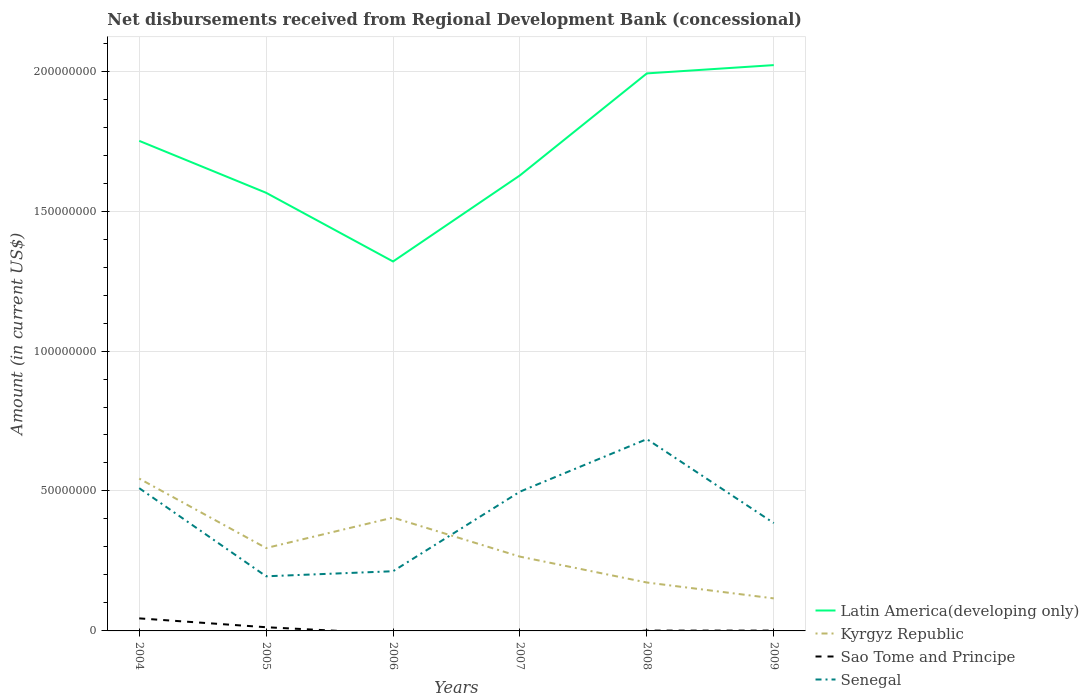Is the number of lines equal to the number of legend labels?
Ensure brevity in your answer.  No. Across all years, what is the maximum amount of disbursements received from Regional Development Bank in Kyrgyz Republic?
Ensure brevity in your answer.  1.16e+07. What is the total amount of disbursements received from Regional Development Bank in Kyrgyz Republic in the graph?
Your response must be concise. 3.71e+07. What is the difference between the highest and the second highest amount of disbursements received from Regional Development Bank in Senegal?
Offer a terse response. 4.90e+07. What is the difference between the highest and the lowest amount of disbursements received from Regional Development Bank in Senegal?
Keep it short and to the point. 3. How many lines are there?
Your answer should be very brief. 4. What is the difference between two consecutive major ticks on the Y-axis?
Offer a terse response. 5.00e+07. Does the graph contain any zero values?
Provide a short and direct response. Yes. Does the graph contain grids?
Provide a succinct answer. Yes. How are the legend labels stacked?
Provide a succinct answer. Vertical. What is the title of the graph?
Offer a very short reply. Net disbursements received from Regional Development Bank (concessional). What is the label or title of the X-axis?
Your response must be concise. Years. What is the Amount (in current US$) of Latin America(developing only) in 2004?
Make the answer very short. 1.75e+08. What is the Amount (in current US$) in Kyrgyz Republic in 2004?
Provide a short and direct response. 5.44e+07. What is the Amount (in current US$) of Sao Tome and Principe in 2004?
Your answer should be compact. 4.48e+06. What is the Amount (in current US$) of Senegal in 2004?
Provide a succinct answer. 5.10e+07. What is the Amount (in current US$) of Latin America(developing only) in 2005?
Provide a succinct answer. 1.57e+08. What is the Amount (in current US$) of Kyrgyz Republic in 2005?
Offer a very short reply. 2.96e+07. What is the Amount (in current US$) of Sao Tome and Principe in 2005?
Offer a very short reply. 1.32e+06. What is the Amount (in current US$) in Senegal in 2005?
Your answer should be very brief. 1.95e+07. What is the Amount (in current US$) of Latin America(developing only) in 2006?
Give a very brief answer. 1.32e+08. What is the Amount (in current US$) of Kyrgyz Republic in 2006?
Provide a succinct answer. 4.05e+07. What is the Amount (in current US$) of Sao Tome and Principe in 2006?
Offer a terse response. 0. What is the Amount (in current US$) in Senegal in 2006?
Your answer should be compact. 2.13e+07. What is the Amount (in current US$) of Latin America(developing only) in 2007?
Ensure brevity in your answer.  1.63e+08. What is the Amount (in current US$) of Kyrgyz Republic in 2007?
Provide a succinct answer. 2.65e+07. What is the Amount (in current US$) of Senegal in 2007?
Provide a succinct answer. 4.98e+07. What is the Amount (in current US$) of Latin America(developing only) in 2008?
Your response must be concise. 1.99e+08. What is the Amount (in current US$) of Kyrgyz Republic in 2008?
Keep it short and to the point. 1.73e+07. What is the Amount (in current US$) of Sao Tome and Principe in 2008?
Offer a very short reply. 1.18e+05. What is the Amount (in current US$) of Senegal in 2008?
Provide a succinct answer. 6.85e+07. What is the Amount (in current US$) of Latin America(developing only) in 2009?
Give a very brief answer. 2.02e+08. What is the Amount (in current US$) of Kyrgyz Republic in 2009?
Provide a short and direct response. 1.16e+07. What is the Amount (in current US$) of Senegal in 2009?
Your answer should be compact. 3.85e+07. Across all years, what is the maximum Amount (in current US$) of Latin America(developing only)?
Give a very brief answer. 2.02e+08. Across all years, what is the maximum Amount (in current US$) of Kyrgyz Republic?
Offer a terse response. 5.44e+07. Across all years, what is the maximum Amount (in current US$) of Sao Tome and Principe?
Offer a very short reply. 4.48e+06. Across all years, what is the maximum Amount (in current US$) of Senegal?
Your answer should be very brief. 6.85e+07. Across all years, what is the minimum Amount (in current US$) in Latin America(developing only)?
Keep it short and to the point. 1.32e+08. Across all years, what is the minimum Amount (in current US$) of Kyrgyz Republic?
Ensure brevity in your answer.  1.16e+07. Across all years, what is the minimum Amount (in current US$) in Senegal?
Your response must be concise. 1.95e+07. What is the total Amount (in current US$) in Latin America(developing only) in the graph?
Your response must be concise. 1.03e+09. What is the total Amount (in current US$) of Kyrgyz Republic in the graph?
Your answer should be very brief. 1.80e+08. What is the total Amount (in current US$) in Sao Tome and Principe in the graph?
Provide a short and direct response. 6.04e+06. What is the total Amount (in current US$) in Senegal in the graph?
Ensure brevity in your answer.  2.49e+08. What is the difference between the Amount (in current US$) in Latin America(developing only) in 2004 and that in 2005?
Offer a terse response. 1.86e+07. What is the difference between the Amount (in current US$) of Kyrgyz Republic in 2004 and that in 2005?
Your answer should be compact. 2.48e+07. What is the difference between the Amount (in current US$) of Sao Tome and Principe in 2004 and that in 2005?
Keep it short and to the point. 3.16e+06. What is the difference between the Amount (in current US$) in Senegal in 2004 and that in 2005?
Make the answer very short. 3.15e+07. What is the difference between the Amount (in current US$) in Latin America(developing only) in 2004 and that in 2006?
Ensure brevity in your answer.  4.31e+07. What is the difference between the Amount (in current US$) in Kyrgyz Republic in 2004 and that in 2006?
Make the answer very short. 1.39e+07. What is the difference between the Amount (in current US$) of Senegal in 2004 and that in 2006?
Give a very brief answer. 2.97e+07. What is the difference between the Amount (in current US$) in Latin America(developing only) in 2004 and that in 2007?
Your answer should be compact. 1.23e+07. What is the difference between the Amount (in current US$) of Kyrgyz Republic in 2004 and that in 2007?
Offer a terse response. 2.79e+07. What is the difference between the Amount (in current US$) in Senegal in 2004 and that in 2007?
Provide a short and direct response. 1.25e+06. What is the difference between the Amount (in current US$) of Latin America(developing only) in 2004 and that in 2008?
Give a very brief answer. -2.41e+07. What is the difference between the Amount (in current US$) of Kyrgyz Republic in 2004 and that in 2008?
Provide a short and direct response. 3.71e+07. What is the difference between the Amount (in current US$) of Sao Tome and Principe in 2004 and that in 2008?
Your response must be concise. 4.37e+06. What is the difference between the Amount (in current US$) of Senegal in 2004 and that in 2008?
Provide a short and direct response. -1.75e+07. What is the difference between the Amount (in current US$) in Latin America(developing only) in 2004 and that in 2009?
Keep it short and to the point. -2.71e+07. What is the difference between the Amount (in current US$) of Kyrgyz Republic in 2004 and that in 2009?
Ensure brevity in your answer.  4.28e+07. What is the difference between the Amount (in current US$) of Sao Tome and Principe in 2004 and that in 2009?
Make the answer very short. 4.36e+06. What is the difference between the Amount (in current US$) in Senegal in 2004 and that in 2009?
Offer a terse response. 1.25e+07. What is the difference between the Amount (in current US$) of Latin America(developing only) in 2005 and that in 2006?
Your response must be concise. 2.45e+07. What is the difference between the Amount (in current US$) of Kyrgyz Republic in 2005 and that in 2006?
Your answer should be compact. -1.09e+07. What is the difference between the Amount (in current US$) of Senegal in 2005 and that in 2006?
Provide a succinct answer. -1.80e+06. What is the difference between the Amount (in current US$) of Latin America(developing only) in 2005 and that in 2007?
Make the answer very short. -6.22e+06. What is the difference between the Amount (in current US$) of Kyrgyz Republic in 2005 and that in 2007?
Keep it short and to the point. 3.07e+06. What is the difference between the Amount (in current US$) in Senegal in 2005 and that in 2007?
Keep it short and to the point. -3.02e+07. What is the difference between the Amount (in current US$) in Latin America(developing only) in 2005 and that in 2008?
Offer a very short reply. -4.27e+07. What is the difference between the Amount (in current US$) of Kyrgyz Republic in 2005 and that in 2008?
Ensure brevity in your answer.  1.23e+07. What is the difference between the Amount (in current US$) of Sao Tome and Principe in 2005 and that in 2008?
Your answer should be very brief. 1.20e+06. What is the difference between the Amount (in current US$) in Senegal in 2005 and that in 2008?
Keep it short and to the point. -4.90e+07. What is the difference between the Amount (in current US$) in Latin America(developing only) in 2005 and that in 2009?
Ensure brevity in your answer.  -4.56e+07. What is the difference between the Amount (in current US$) of Kyrgyz Republic in 2005 and that in 2009?
Your answer should be compact. 1.80e+07. What is the difference between the Amount (in current US$) of Sao Tome and Principe in 2005 and that in 2009?
Offer a very short reply. 1.20e+06. What is the difference between the Amount (in current US$) in Senegal in 2005 and that in 2009?
Your answer should be compact. -1.90e+07. What is the difference between the Amount (in current US$) in Latin America(developing only) in 2006 and that in 2007?
Your answer should be compact. -3.08e+07. What is the difference between the Amount (in current US$) in Kyrgyz Republic in 2006 and that in 2007?
Give a very brief answer. 1.39e+07. What is the difference between the Amount (in current US$) in Senegal in 2006 and that in 2007?
Your answer should be very brief. -2.84e+07. What is the difference between the Amount (in current US$) in Latin America(developing only) in 2006 and that in 2008?
Offer a terse response. -6.72e+07. What is the difference between the Amount (in current US$) in Kyrgyz Republic in 2006 and that in 2008?
Keep it short and to the point. 2.32e+07. What is the difference between the Amount (in current US$) in Senegal in 2006 and that in 2008?
Make the answer very short. -4.72e+07. What is the difference between the Amount (in current US$) in Latin America(developing only) in 2006 and that in 2009?
Your response must be concise. -7.02e+07. What is the difference between the Amount (in current US$) of Kyrgyz Republic in 2006 and that in 2009?
Give a very brief answer. 2.89e+07. What is the difference between the Amount (in current US$) in Senegal in 2006 and that in 2009?
Offer a very short reply. -1.72e+07. What is the difference between the Amount (in current US$) in Latin America(developing only) in 2007 and that in 2008?
Your response must be concise. -3.64e+07. What is the difference between the Amount (in current US$) in Kyrgyz Republic in 2007 and that in 2008?
Offer a terse response. 9.25e+06. What is the difference between the Amount (in current US$) of Senegal in 2007 and that in 2008?
Offer a terse response. -1.88e+07. What is the difference between the Amount (in current US$) in Latin America(developing only) in 2007 and that in 2009?
Offer a terse response. -3.94e+07. What is the difference between the Amount (in current US$) in Kyrgyz Republic in 2007 and that in 2009?
Your answer should be very brief. 1.49e+07. What is the difference between the Amount (in current US$) in Senegal in 2007 and that in 2009?
Provide a succinct answer. 1.12e+07. What is the difference between the Amount (in current US$) in Latin America(developing only) in 2008 and that in 2009?
Offer a terse response. -2.96e+06. What is the difference between the Amount (in current US$) in Kyrgyz Republic in 2008 and that in 2009?
Your answer should be very brief. 5.67e+06. What is the difference between the Amount (in current US$) of Sao Tome and Principe in 2008 and that in 2009?
Your answer should be very brief. -2000. What is the difference between the Amount (in current US$) of Senegal in 2008 and that in 2009?
Your answer should be very brief. 3.00e+07. What is the difference between the Amount (in current US$) in Latin America(developing only) in 2004 and the Amount (in current US$) in Kyrgyz Republic in 2005?
Give a very brief answer. 1.45e+08. What is the difference between the Amount (in current US$) of Latin America(developing only) in 2004 and the Amount (in current US$) of Sao Tome and Principe in 2005?
Your answer should be compact. 1.74e+08. What is the difference between the Amount (in current US$) of Latin America(developing only) in 2004 and the Amount (in current US$) of Senegal in 2005?
Ensure brevity in your answer.  1.56e+08. What is the difference between the Amount (in current US$) of Kyrgyz Republic in 2004 and the Amount (in current US$) of Sao Tome and Principe in 2005?
Your answer should be very brief. 5.31e+07. What is the difference between the Amount (in current US$) in Kyrgyz Republic in 2004 and the Amount (in current US$) in Senegal in 2005?
Offer a terse response. 3.49e+07. What is the difference between the Amount (in current US$) in Sao Tome and Principe in 2004 and the Amount (in current US$) in Senegal in 2005?
Offer a very short reply. -1.50e+07. What is the difference between the Amount (in current US$) in Latin America(developing only) in 2004 and the Amount (in current US$) in Kyrgyz Republic in 2006?
Your answer should be very brief. 1.35e+08. What is the difference between the Amount (in current US$) in Latin America(developing only) in 2004 and the Amount (in current US$) in Senegal in 2006?
Ensure brevity in your answer.  1.54e+08. What is the difference between the Amount (in current US$) in Kyrgyz Republic in 2004 and the Amount (in current US$) in Senegal in 2006?
Your response must be concise. 3.31e+07. What is the difference between the Amount (in current US$) of Sao Tome and Principe in 2004 and the Amount (in current US$) of Senegal in 2006?
Give a very brief answer. -1.68e+07. What is the difference between the Amount (in current US$) of Latin America(developing only) in 2004 and the Amount (in current US$) of Kyrgyz Republic in 2007?
Make the answer very short. 1.49e+08. What is the difference between the Amount (in current US$) in Latin America(developing only) in 2004 and the Amount (in current US$) in Senegal in 2007?
Your answer should be very brief. 1.25e+08. What is the difference between the Amount (in current US$) of Kyrgyz Republic in 2004 and the Amount (in current US$) of Senegal in 2007?
Keep it short and to the point. 4.66e+06. What is the difference between the Amount (in current US$) of Sao Tome and Principe in 2004 and the Amount (in current US$) of Senegal in 2007?
Your answer should be compact. -4.53e+07. What is the difference between the Amount (in current US$) of Latin America(developing only) in 2004 and the Amount (in current US$) of Kyrgyz Republic in 2008?
Provide a short and direct response. 1.58e+08. What is the difference between the Amount (in current US$) in Latin America(developing only) in 2004 and the Amount (in current US$) in Sao Tome and Principe in 2008?
Offer a very short reply. 1.75e+08. What is the difference between the Amount (in current US$) of Latin America(developing only) in 2004 and the Amount (in current US$) of Senegal in 2008?
Provide a succinct answer. 1.07e+08. What is the difference between the Amount (in current US$) in Kyrgyz Republic in 2004 and the Amount (in current US$) in Sao Tome and Principe in 2008?
Your answer should be very brief. 5.43e+07. What is the difference between the Amount (in current US$) in Kyrgyz Republic in 2004 and the Amount (in current US$) in Senegal in 2008?
Keep it short and to the point. -1.41e+07. What is the difference between the Amount (in current US$) in Sao Tome and Principe in 2004 and the Amount (in current US$) in Senegal in 2008?
Your answer should be very brief. -6.40e+07. What is the difference between the Amount (in current US$) in Latin America(developing only) in 2004 and the Amount (in current US$) in Kyrgyz Republic in 2009?
Provide a succinct answer. 1.63e+08. What is the difference between the Amount (in current US$) of Latin America(developing only) in 2004 and the Amount (in current US$) of Sao Tome and Principe in 2009?
Keep it short and to the point. 1.75e+08. What is the difference between the Amount (in current US$) of Latin America(developing only) in 2004 and the Amount (in current US$) of Senegal in 2009?
Keep it short and to the point. 1.37e+08. What is the difference between the Amount (in current US$) in Kyrgyz Republic in 2004 and the Amount (in current US$) in Sao Tome and Principe in 2009?
Ensure brevity in your answer.  5.43e+07. What is the difference between the Amount (in current US$) in Kyrgyz Republic in 2004 and the Amount (in current US$) in Senegal in 2009?
Your answer should be very brief. 1.59e+07. What is the difference between the Amount (in current US$) in Sao Tome and Principe in 2004 and the Amount (in current US$) in Senegal in 2009?
Make the answer very short. -3.40e+07. What is the difference between the Amount (in current US$) in Latin America(developing only) in 2005 and the Amount (in current US$) in Kyrgyz Republic in 2006?
Ensure brevity in your answer.  1.16e+08. What is the difference between the Amount (in current US$) of Latin America(developing only) in 2005 and the Amount (in current US$) of Senegal in 2006?
Make the answer very short. 1.35e+08. What is the difference between the Amount (in current US$) of Kyrgyz Republic in 2005 and the Amount (in current US$) of Senegal in 2006?
Offer a very short reply. 8.29e+06. What is the difference between the Amount (in current US$) in Sao Tome and Principe in 2005 and the Amount (in current US$) in Senegal in 2006?
Make the answer very short. -2.00e+07. What is the difference between the Amount (in current US$) of Latin America(developing only) in 2005 and the Amount (in current US$) of Kyrgyz Republic in 2007?
Give a very brief answer. 1.30e+08. What is the difference between the Amount (in current US$) in Latin America(developing only) in 2005 and the Amount (in current US$) in Senegal in 2007?
Your answer should be compact. 1.07e+08. What is the difference between the Amount (in current US$) in Kyrgyz Republic in 2005 and the Amount (in current US$) in Senegal in 2007?
Provide a short and direct response. -2.01e+07. What is the difference between the Amount (in current US$) of Sao Tome and Principe in 2005 and the Amount (in current US$) of Senegal in 2007?
Give a very brief answer. -4.84e+07. What is the difference between the Amount (in current US$) in Latin America(developing only) in 2005 and the Amount (in current US$) in Kyrgyz Republic in 2008?
Provide a short and direct response. 1.39e+08. What is the difference between the Amount (in current US$) of Latin America(developing only) in 2005 and the Amount (in current US$) of Sao Tome and Principe in 2008?
Offer a terse response. 1.56e+08. What is the difference between the Amount (in current US$) of Latin America(developing only) in 2005 and the Amount (in current US$) of Senegal in 2008?
Give a very brief answer. 8.80e+07. What is the difference between the Amount (in current US$) in Kyrgyz Republic in 2005 and the Amount (in current US$) in Sao Tome and Principe in 2008?
Offer a very short reply. 2.95e+07. What is the difference between the Amount (in current US$) of Kyrgyz Republic in 2005 and the Amount (in current US$) of Senegal in 2008?
Ensure brevity in your answer.  -3.89e+07. What is the difference between the Amount (in current US$) in Sao Tome and Principe in 2005 and the Amount (in current US$) in Senegal in 2008?
Offer a terse response. -6.72e+07. What is the difference between the Amount (in current US$) in Latin America(developing only) in 2005 and the Amount (in current US$) in Kyrgyz Republic in 2009?
Provide a short and direct response. 1.45e+08. What is the difference between the Amount (in current US$) of Latin America(developing only) in 2005 and the Amount (in current US$) of Sao Tome and Principe in 2009?
Provide a short and direct response. 1.56e+08. What is the difference between the Amount (in current US$) in Latin America(developing only) in 2005 and the Amount (in current US$) in Senegal in 2009?
Ensure brevity in your answer.  1.18e+08. What is the difference between the Amount (in current US$) of Kyrgyz Republic in 2005 and the Amount (in current US$) of Sao Tome and Principe in 2009?
Offer a terse response. 2.95e+07. What is the difference between the Amount (in current US$) of Kyrgyz Republic in 2005 and the Amount (in current US$) of Senegal in 2009?
Make the answer very short. -8.92e+06. What is the difference between the Amount (in current US$) of Sao Tome and Principe in 2005 and the Amount (in current US$) of Senegal in 2009?
Provide a succinct answer. -3.72e+07. What is the difference between the Amount (in current US$) in Latin America(developing only) in 2006 and the Amount (in current US$) in Kyrgyz Republic in 2007?
Offer a very short reply. 1.05e+08. What is the difference between the Amount (in current US$) of Latin America(developing only) in 2006 and the Amount (in current US$) of Senegal in 2007?
Offer a terse response. 8.22e+07. What is the difference between the Amount (in current US$) of Kyrgyz Republic in 2006 and the Amount (in current US$) of Senegal in 2007?
Provide a short and direct response. -9.27e+06. What is the difference between the Amount (in current US$) in Latin America(developing only) in 2006 and the Amount (in current US$) in Kyrgyz Republic in 2008?
Your response must be concise. 1.15e+08. What is the difference between the Amount (in current US$) in Latin America(developing only) in 2006 and the Amount (in current US$) in Sao Tome and Principe in 2008?
Keep it short and to the point. 1.32e+08. What is the difference between the Amount (in current US$) in Latin America(developing only) in 2006 and the Amount (in current US$) in Senegal in 2008?
Your answer should be very brief. 6.35e+07. What is the difference between the Amount (in current US$) in Kyrgyz Republic in 2006 and the Amount (in current US$) in Sao Tome and Principe in 2008?
Provide a short and direct response. 4.04e+07. What is the difference between the Amount (in current US$) of Kyrgyz Republic in 2006 and the Amount (in current US$) of Senegal in 2008?
Your response must be concise. -2.80e+07. What is the difference between the Amount (in current US$) of Latin America(developing only) in 2006 and the Amount (in current US$) of Kyrgyz Republic in 2009?
Your answer should be compact. 1.20e+08. What is the difference between the Amount (in current US$) in Latin America(developing only) in 2006 and the Amount (in current US$) in Sao Tome and Principe in 2009?
Your answer should be compact. 1.32e+08. What is the difference between the Amount (in current US$) in Latin America(developing only) in 2006 and the Amount (in current US$) in Senegal in 2009?
Provide a succinct answer. 9.35e+07. What is the difference between the Amount (in current US$) in Kyrgyz Republic in 2006 and the Amount (in current US$) in Sao Tome and Principe in 2009?
Keep it short and to the point. 4.04e+07. What is the difference between the Amount (in current US$) in Kyrgyz Republic in 2006 and the Amount (in current US$) in Senegal in 2009?
Your answer should be compact. 1.95e+06. What is the difference between the Amount (in current US$) of Latin America(developing only) in 2007 and the Amount (in current US$) of Kyrgyz Republic in 2008?
Give a very brief answer. 1.45e+08. What is the difference between the Amount (in current US$) of Latin America(developing only) in 2007 and the Amount (in current US$) of Sao Tome and Principe in 2008?
Make the answer very short. 1.63e+08. What is the difference between the Amount (in current US$) of Latin America(developing only) in 2007 and the Amount (in current US$) of Senegal in 2008?
Your answer should be compact. 9.42e+07. What is the difference between the Amount (in current US$) in Kyrgyz Republic in 2007 and the Amount (in current US$) in Sao Tome and Principe in 2008?
Make the answer very short. 2.64e+07. What is the difference between the Amount (in current US$) of Kyrgyz Republic in 2007 and the Amount (in current US$) of Senegal in 2008?
Your answer should be compact. -4.20e+07. What is the difference between the Amount (in current US$) of Latin America(developing only) in 2007 and the Amount (in current US$) of Kyrgyz Republic in 2009?
Make the answer very short. 1.51e+08. What is the difference between the Amount (in current US$) in Latin America(developing only) in 2007 and the Amount (in current US$) in Sao Tome and Principe in 2009?
Give a very brief answer. 1.63e+08. What is the difference between the Amount (in current US$) of Latin America(developing only) in 2007 and the Amount (in current US$) of Senegal in 2009?
Your response must be concise. 1.24e+08. What is the difference between the Amount (in current US$) of Kyrgyz Republic in 2007 and the Amount (in current US$) of Sao Tome and Principe in 2009?
Make the answer very short. 2.64e+07. What is the difference between the Amount (in current US$) in Kyrgyz Republic in 2007 and the Amount (in current US$) in Senegal in 2009?
Keep it short and to the point. -1.20e+07. What is the difference between the Amount (in current US$) of Latin America(developing only) in 2008 and the Amount (in current US$) of Kyrgyz Republic in 2009?
Ensure brevity in your answer.  1.88e+08. What is the difference between the Amount (in current US$) of Latin America(developing only) in 2008 and the Amount (in current US$) of Sao Tome and Principe in 2009?
Give a very brief answer. 1.99e+08. What is the difference between the Amount (in current US$) in Latin America(developing only) in 2008 and the Amount (in current US$) in Senegal in 2009?
Provide a succinct answer. 1.61e+08. What is the difference between the Amount (in current US$) in Kyrgyz Republic in 2008 and the Amount (in current US$) in Sao Tome and Principe in 2009?
Give a very brief answer. 1.72e+07. What is the difference between the Amount (in current US$) of Kyrgyz Republic in 2008 and the Amount (in current US$) of Senegal in 2009?
Provide a short and direct response. -2.12e+07. What is the difference between the Amount (in current US$) of Sao Tome and Principe in 2008 and the Amount (in current US$) of Senegal in 2009?
Your answer should be very brief. -3.84e+07. What is the average Amount (in current US$) in Latin America(developing only) per year?
Ensure brevity in your answer.  1.71e+08. What is the average Amount (in current US$) in Kyrgyz Republic per year?
Give a very brief answer. 3.00e+07. What is the average Amount (in current US$) in Sao Tome and Principe per year?
Your response must be concise. 1.01e+06. What is the average Amount (in current US$) of Senegal per year?
Keep it short and to the point. 4.14e+07. In the year 2004, what is the difference between the Amount (in current US$) of Latin America(developing only) and Amount (in current US$) of Kyrgyz Republic?
Offer a terse response. 1.21e+08. In the year 2004, what is the difference between the Amount (in current US$) of Latin America(developing only) and Amount (in current US$) of Sao Tome and Principe?
Keep it short and to the point. 1.71e+08. In the year 2004, what is the difference between the Amount (in current US$) of Latin America(developing only) and Amount (in current US$) of Senegal?
Provide a short and direct response. 1.24e+08. In the year 2004, what is the difference between the Amount (in current US$) in Kyrgyz Republic and Amount (in current US$) in Sao Tome and Principe?
Your answer should be compact. 4.99e+07. In the year 2004, what is the difference between the Amount (in current US$) of Kyrgyz Republic and Amount (in current US$) of Senegal?
Provide a succinct answer. 3.42e+06. In the year 2004, what is the difference between the Amount (in current US$) in Sao Tome and Principe and Amount (in current US$) in Senegal?
Provide a short and direct response. -4.65e+07. In the year 2005, what is the difference between the Amount (in current US$) in Latin America(developing only) and Amount (in current US$) in Kyrgyz Republic?
Provide a short and direct response. 1.27e+08. In the year 2005, what is the difference between the Amount (in current US$) of Latin America(developing only) and Amount (in current US$) of Sao Tome and Principe?
Provide a succinct answer. 1.55e+08. In the year 2005, what is the difference between the Amount (in current US$) in Latin America(developing only) and Amount (in current US$) in Senegal?
Offer a very short reply. 1.37e+08. In the year 2005, what is the difference between the Amount (in current US$) of Kyrgyz Republic and Amount (in current US$) of Sao Tome and Principe?
Keep it short and to the point. 2.83e+07. In the year 2005, what is the difference between the Amount (in current US$) in Kyrgyz Republic and Amount (in current US$) in Senegal?
Offer a very short reply. 1.01e+07. In the year 2005, what is the difference between the Amount (in current US$) of Sao Tome and Principe and Amount (in current US$) of Senegal?
Make the answer very short. -1.82e+07. In the year 2006, what is the difference between the Amount (in current US$) in Latin America(developing only) and Amount (in current US$) in Kyrgyz Republic?
Give a very brief answer. 9.15e+07. In the year 2006, what is the difference between the Amount (in current US$) in Latin America(developing only) and Amount (in current US$) in Senegal?
Keep it short and to the point. 1.11e+08. In the year 2006, what is the difference between the Amount (in current US$) of Kyrgyz Republic and Amount (in current US$) of Senegal?
Your answer should be very brief. 1.92e+07. In the year 2007, what is the difference between the Amount (in current US$) in Latin America(developing only) and Amount (in current US$) in Kyrgyz Republic?
Your answer should be compact. 1.36e+08. In the year 2007, what is the difference between the Amount (in current US$) in Latin America(developing only) and Amount (in current US$) in Senegal?
Provide a succinct answer. 1.13e+08. In the year 2007, what is the difference between the Amount (in current US$) in Kyrgyz Republic and Amount (in current US$) in Senegal?
Offer a very short reply. -2.32e+07. In the year 2008, what is the difference between the Amount (in current US$) in Latin America(developing only) and Amount (in current US$) in Kyrgyz Republic?
Your answer should be compact. 1.82e+08. In the year 2008, what is the difference between the Amount (in current US$) of Latin America(developing only) and Amount (in current US$) of Sao Tome and Principe?
Ensure brevity in your answer.  1.99e+08. In the year 2008, what is the difference between the Amount (in current US$) of Latin America(developing only) and Amount (in current US$) of Senegal?
Keep it short and to the point. 1.31e+08. In the year 2008, what is the difference between the Amount (in current US$) in Kyrgyz Republic and Amount (in current US$) in Sao Tome and Principe?
Ensure brevity in your answer.  1.72e+07. In the year 2008, what is the difference between the Amount (in current US$) in Kyrgyz Republic and Amount (in current US$) in Senegal?
Provide a succinct answer. -5.12e+07. In the year 2008, what is the difference between the Amount (in current US$) in Sao Tome and Principe and Amount (in current US$) in Senegal?
Your response must be concise. -6.84e+07. In the year 2009, what is the difference between the Amount (in current US$) in Latin America(developing only) and Amount (in current US$) in Kyrgyz Republic?
Your answer should be very brief. 1.91e+08. In the year 2009, what is the difference between the Amount (in current US$) of Latin America(developing only) and Amount (in current US$) of Sao Tome and Principe?
Provide a short and direct response. 2.02e+08. In the year 2009, what is the difference between the Amount (in current US$) in Latin America(developing only) and Amount (in current US$) in Senegal?
Offer a very short reply. 1.64e+08. In the year 2009, what is the difference between the Amount (in current US$) of Kyrgyz Republic and Amount (in current US$) of Sao Tome and Principe?
Your answer should be compact. 1.15e+07. In the year 2009, what is the difference between the Amount (in current US$) of Kyrgyz Republic and Amount (in current US$) of Senegal?
Provide a short and direct response. -2.69e+07. In the year 2009, what is the difference between the Amount (in current US$) of Sao Tome and Principe and Amount (in current US$) of Senegal?
Keep it short and to the point. -3.84e+07. What is the ratio of the Amount (in current US$) of Latin America(developing only) in 2004 to that in 2005?
Provide a succinct answer. 1.12. What is the ratio of the Amount (in current US$) in Kyrgyz Republic in 2004 to that in 2005?
Provide a succinct answer. 1.84. What is the ratio of the Amount (in current US$) of Sao Tome and Principe in 2004 to that in 2005?
Your answer should be very brief. 3.39. What is the ratio of the Amount (in current US$) of Senegal in 2004 to that in 2005?
Your response must be concise. 2.61. What is the ratio of the Amount (in current US$) in Latin America(developing only) in 2004 to that in 2006?
Your answer should be compact. 1.33. What is the ratio of the Amount (in current US$) in Kyrgyz Republic in 2004 to that in 2006?
Provide a succinct answer. 1.34. What is the ratio of the Amount (in current US$) of Senegal in 2004 to that in 2006?
Make the answer very short. 2.39. What is the ratio of the Amount (in current US$) in Latin America(developing only) in 2004 to that in 2007?
Give a very brief answer. 1.08. What is the ratio of the Amount (in current US$) of Kyrgyz Republic in 2004 to that in 2007?
Offer a very short reply. 2.05. What is the ratio of the Amount (in current US$) of Senegal in 2004 to that in 2007?
Ensure brevity in your answer.  1.03. What is the ratio of the Amount (in current US$) in Latin America(developing only) in 2004 to that in 2008?
Offer a terse response. 0.88. What is the ratio of the Amount (in current US$) of Kyrgyz Republic in 2004 to that in 2008?
Provide a succinct answer. 3.15. What is the ratio of the Amount (in current US$) of Senegal in 2004 to that in 2008?
Your response must be concise. 0.74. What is the ratio of the Amount (in current US$) in Latin America(developing only) in 2004 to that in 2009?
Keep it short and to the point. 0.87. What is the ratio of the Amount (in current US$) of Kyrgyz Republic in 2004 to that in 2009?
Your response must be concise. 4.68. What is the ratio of the Amount (in current US$) in Sao Tome and Principe in 2004 to that in 2009?
Your answer should be compact. 37.37. What is the ratio of the Amount (in current US$) in Senegal in 2004 to that in 2009?
Offer a terse response. 1.32. What is the ratio of the Amount (in current US$) of Latin America(developing only) in 2005 to that in 2006?
Ensure brevity in your answer.  1.19. What is the ratio of the Amount (in current US$) in Kyrgyz Republic in 2005 to that in 2006?
Your answer should be very brief. 0.73. What is the ratio of the Amount (in current US$) of Senegal in 2005 to that in 2006?
Offer a very short reply. 0.92. What is the ratio of the Amount (in current US$) in Latin America(developing only) in 2005 to that in 2007?
Keep it short and to the point. 0.96. What is the ratio of the Amount (in current US$) of Kyrgyz Republic in 2005 to that in 2007?
Offer a terse response. 1.12. What is the ratio of the Amount (in current US$) of Senegal in 2005 to that in 2007?
Make the answer very short. 0.39. What is the ratio of the Amount (in current US$) in Latin America(developing only) in 2005 to that in 2008?
Offer a terse response. 0.79. What is the ratio of the Amount (in current US$) in Kyrgyz Republic in 2005 to that in 2008?
Your answer should be very brief. 1.71. What is the ratio of the Amount (in current US$) in Sao Tome and Principe in 2005 to that in 2008?
Provide a short and direct response. 11.19. What is the ratio of the Amount (in current US$) of Senegal in 2005 to that in 2008?
Provide a succinct answer. 0.28. What is the ratio of the Amount (in current US$) of Latin America(developing only) in 2005 to that in 2009?
Your answer should be compact. 0.77. What is the ratio of the Amount (in current US$) of Kyrgyz Republic in 2005 to that in 2009?
Your answer should be very brief. 2.55. What is the ratio of the Amount (in current US$) of Sao Tome and Principe in 2005 to that in 2009?
Your answer should be compact. 11.01. What is the ratio of the Amount (in current US$) in Senegal in 2005 to that in 2009?
Your response must be concise. 0.51. What is the ratio of the Amount (in current US$) of Latin America(developing only) in 2006 to that in 2007?
Provide a succinct answer. 0.81. What is the ratio of the Amount (in current US$) of Kyrgyz Republic in 2006 to that in 2007?
Keep it short and to the point. 1.53. What is the ratio of the Amount (in current US$) of Senegal in 2006 to that in 2007?
Your answer should be compact. 0.43. What is the ratio of the Amount (in current US$) in Latin America(developing only) in 2006 to that in 2008?
Ensure brevity in your answer.  0.66. What is the ratio of the Amount (in current US$) of Kyrgyz Republic in 2006 to that in 2008?
Provide a succinct answer. 2.34. What is the ratio of the Amount (in current US$) in Senegal in 2006 to that in 2008?
Keep it short and to the point. 0.31. What is the ratio of the Amount (in current US$) of Latin America(developing only) in 2006 to that in 2009?
Offer a very short reply. 0.65. What is the ratio of the Amount (in current US$) of Kyrgyz Republic in 2006 to that in 2009?
Give a very brief answer. 3.48. What is the ratio of the Amount (in current US$) in Senegal in 2006 to that in 2009?
Offer a terse response. 0.55. What is the ratio of the Amount (in current US$) of Latin America(developing only) in 2007 to that in 2008?
Provide a succinct answer. 0.82. What is the ratio of the Amount (in current US$) of Kyrgyz Republic in 2007 to that in 2008?
Provide a succinct answer. 1.53. What is the ratio of the Amount (in current US$) in Senegal in 2007 to that in 2008?
Provide a succinct answer. 0.73. What is the ratio of the Amount (in current US$) of Latin America(developing only) in 2007 to that in 2009?
Keep it short and to the point. 0.81. What is the ratio of the Amount (in current US$) in Kyrgyz Republic in 2007 to that in 2009?
Your answer should be very brief. 2.28. What is the ratio of the Amount (in current US$) in Senegal in 2007 to that in 2009?
Ensure brevity in your answer.  1.29. What is the ratio of the Amount (in current US$) in Latin America(developing only) in 2008 to that in 2009?
Your response must be concise. 0.99. What is the ratio of the Amount (in current US$) in Kyrgyz Republic in 2008 to that in 2009?
Give a very brief answer. 1.49. What is the ratio of the Amount (in current US$) in Sao Tome and Principe in 2008 to that in 2009?
Your answer should be compact. 0.98. What is the ratio of the Amount (in current US$) of Senegal in 2008 to that in 2009?
Your answer should be very brief. 1.78. What is the difference between the highest and the second highest Amount (in current US$) in Latin America(developing only)?
Provide a succinct answer. 2.96e+06. What is the difference between the highest and the second highest Amount (in current US$) of Kyrgyz Republic?
Offer a terse response. 1.39e+07. What is the difference between the highest and the second highest Amount (in current US$) of Sao Tome and Principe?
Offer a very short reply. 3.16e+06. What is the difference between the highest and the second highest Amount (in current US$) in Senegal?
Provide a succinct answer. 1.75e+07. What is the difference between the highest and the lowest Amount (in current US$) in Latin America(developing only)?
Give a very brief answer. 7.02e+07. What is the difference between the highest and the lowest Amount (in current US$) in Kyrgyz Republic?
Give a very brief answer. 4.28e+07. What is the difference between the highest and the lowest Amount (in current US$) of Sao Tome and Principe?
Ensure brevity in your answer.  4.48e+06. What is the difference between the highest and the lowest Amount (in current US$) in Senegal?
Offer a very short reply. 4.90e+07. 